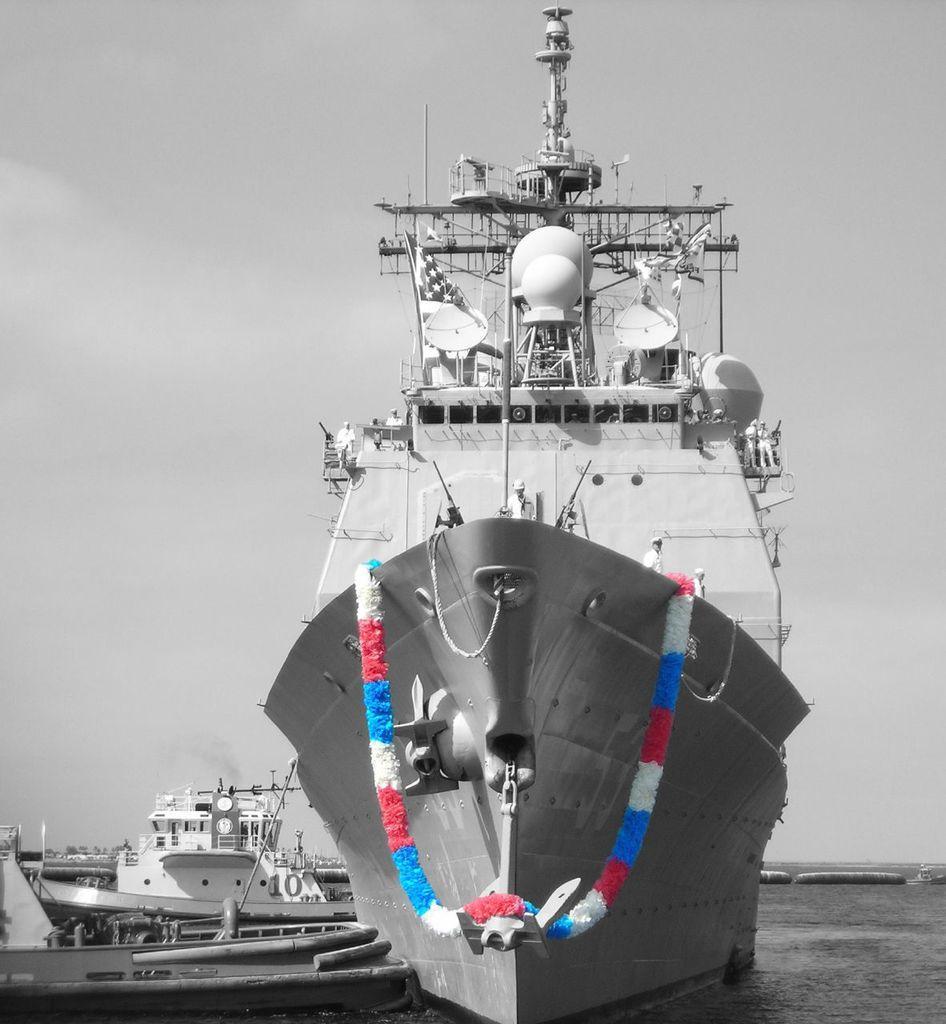Can you describe this image briefly? This is a black and white image, in this image there are ships on a sea, for one ship there is a garland, on that ship there are three men standing, in the background there is the sky. 